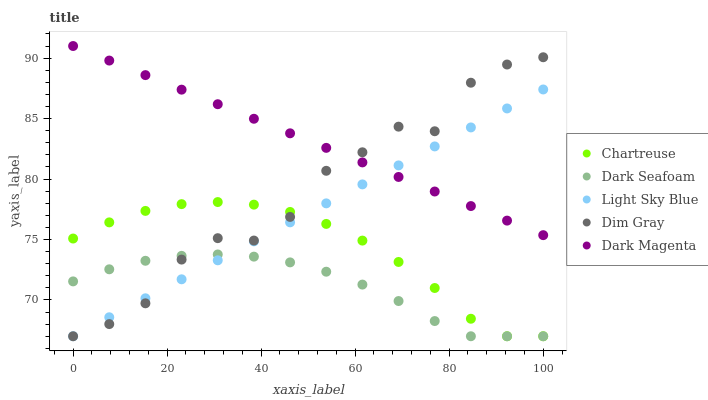Does Dark Seafoam have the minimum area under the curve?
Answer yes or no. Yes. Does Dark Magenta have the maximum area under the curve?
Answer yes or no. Yes. Does Light Sky Blue have the minimum area under the curve?
Answer yes or no. No. Does Light Sky Blue have the maximum area under the curve?
Answer yes or no. No. Is Dark Magenta the smoothest?
Answer yes or no. Yes. Is Dim Gray the roughest?
Answer yes or no. Yes. Is Light Sky Blue the smoothest?
Answer yes or no. No. Is Light Sky Blue the roughest?
Answer yes or no. No. Does Chartreuse have the lowest value?
Answer yes or no. Yes. Does Dark Magenta have the lowest value?
Answer yes or no. No. Does Dark Magenta have the highest value?
Answer yes or no. Yes. Does Light Sky Blue have the highest value?
Answer yes or no. No. Is Dark Seafoam less than Dark Magenta?
Answer yes or no. Yes. Is Dark Magenta greater than Chartreuse?
Answer yes or no. Yes. Does Dim Gray intersect Dark Seafoam?
Answer yes or no. Yes. Is Dim Gray less than Dark Seafoam?
Answer yes or no. No. Is Dim Gray greater than Dark Seafoam?
Answer yes or no. No. Does Dark Seafoam intersect Dark Magenta?
Answer yes or no. No. 